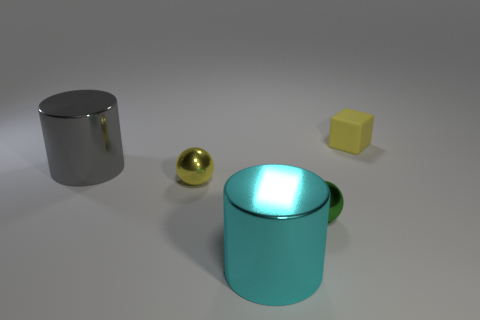What number of other objects are there of the same color as the rubber cube?
Offer a terse response. 1. Is the number of large cyan metal things left of the small yellow shiny thing less than the number of yellow matte things that are in front of the tiny green thing?
Offer a very short reply. No. Do the green shiny thing and the metallic cylinder that is left of the cyan cylinder have the same size?
Provide a short and direct response. No. What number of yellow metallic things are the same size as the yellow ball?
Ensure brevity in your answer.  0. There is another cylinder that is made of the same material as the big gray cylinder; what color is it?
Make the answer very short. Cyan. Is the number of tiny rubber blocks greater than the number of small spheres?
Ensure brevity in your answer.  No. Is the material of the small green sphere the same as the cyan object?
Your response must be concise. Yes. What is the shape of the tiny yellow thing that is made of the same material as the cyan thing?
Give a very brief answer. Sphere. Are there fewer tiny shiny things than large gray matte cubes?
Provide a short and direct response. No. There is a thing that is behind the tiny yellow metallic object and right of the gray cylinder; what material is it made of?
Your response must be concise. Rubber. 